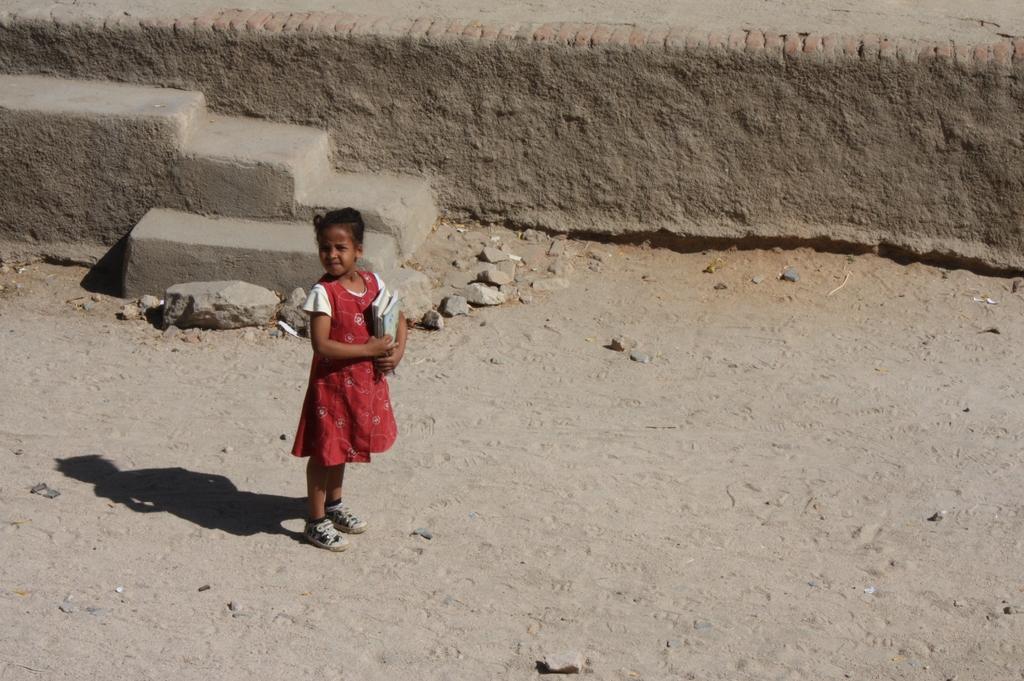How would you summarize this image in a sentence or two? In this picture we can see a girl in a red dress holding books in her hands. She is standing on the ground and looking at someone. Behind her we can see a brick wall, stones & stairs. 